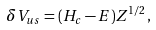<formula> <loc_0><loc_0><loc_500><loc_500>\delta V _ { u s } = ( H _ { c } - E ) Z ^ { 1 / 2 } \, ,</formula> 